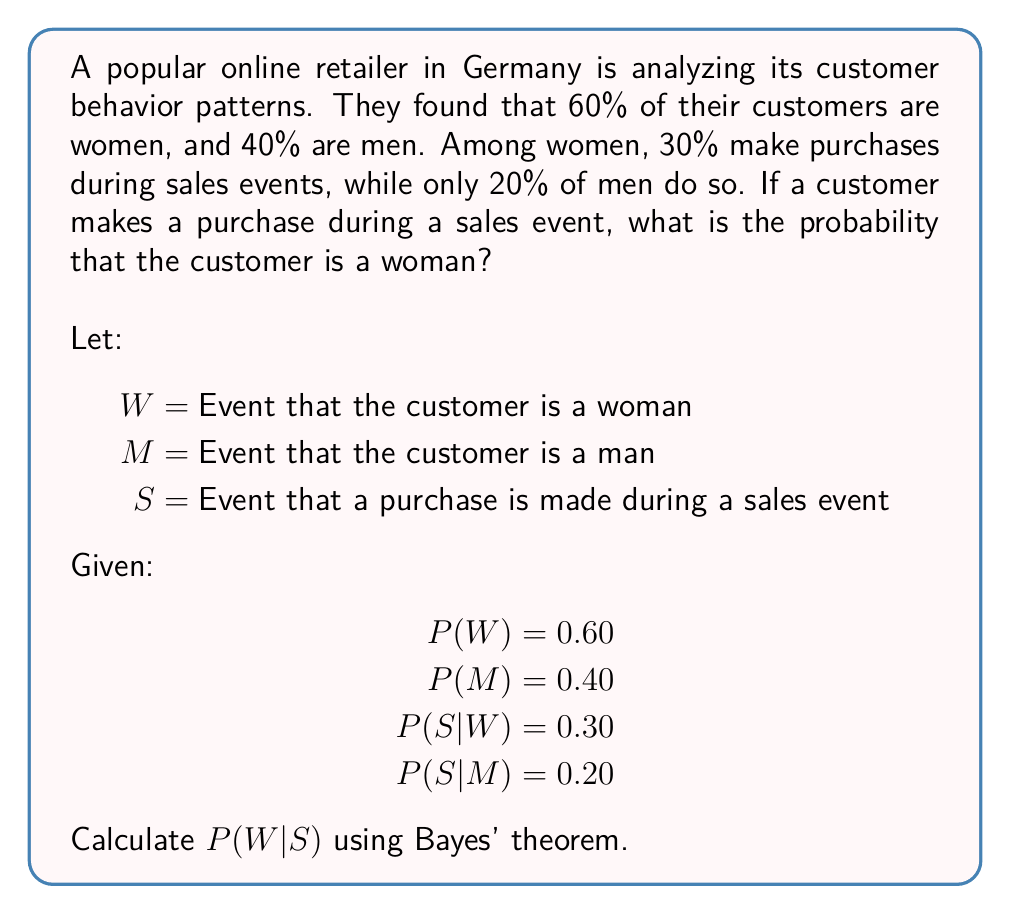Teach me how to tackle this problem. To solve this problem, we'll use Bayes' theorem, which is particularly useful in conditional probability scenarios like this one. Bayes' theorem states:

$$P(A|B) = \frac{P(B|A) \cdot P(A)}{P(B)}$$

In our case, we want to find P(W|S). Let's follow these steps:

1. Identify the given probabilities:
   P(W) = 0.60
   P(M) = 0.40
   P(S|W) = 0.30
   P(S|M) = 0.20

2. Calculate P(S) using the law of total probability:
   $$P(S) = P(S|W) \cdot P(W) + P(S|M) \cdot P(M)$$
   $$P(S) = 0.30 \cdot 0.60 + 0.20 \cdot 0.40$$
   $$P(S) = 0.18 + 0.08 = 0.26$$

3. Apply Bayes' theorem:
   $$P(W|S) = \frac{P(S|W) \cdot P(W)}{P(S)}$$

4. Substitute the values:
   $$P(W|S) = \frac{0.30 \cdot 0.60}{0.26}$$

5. Calculate the final result:
   $$P(W|S) = \frac{0.18}{0.26} \approx 0.6923$$

Therefore, the probability that a customer who makes a purchase during a sales event is a woman is approximately 0.6923 or 69.23%.
Answer: 0.6923 (or 69.23%) 